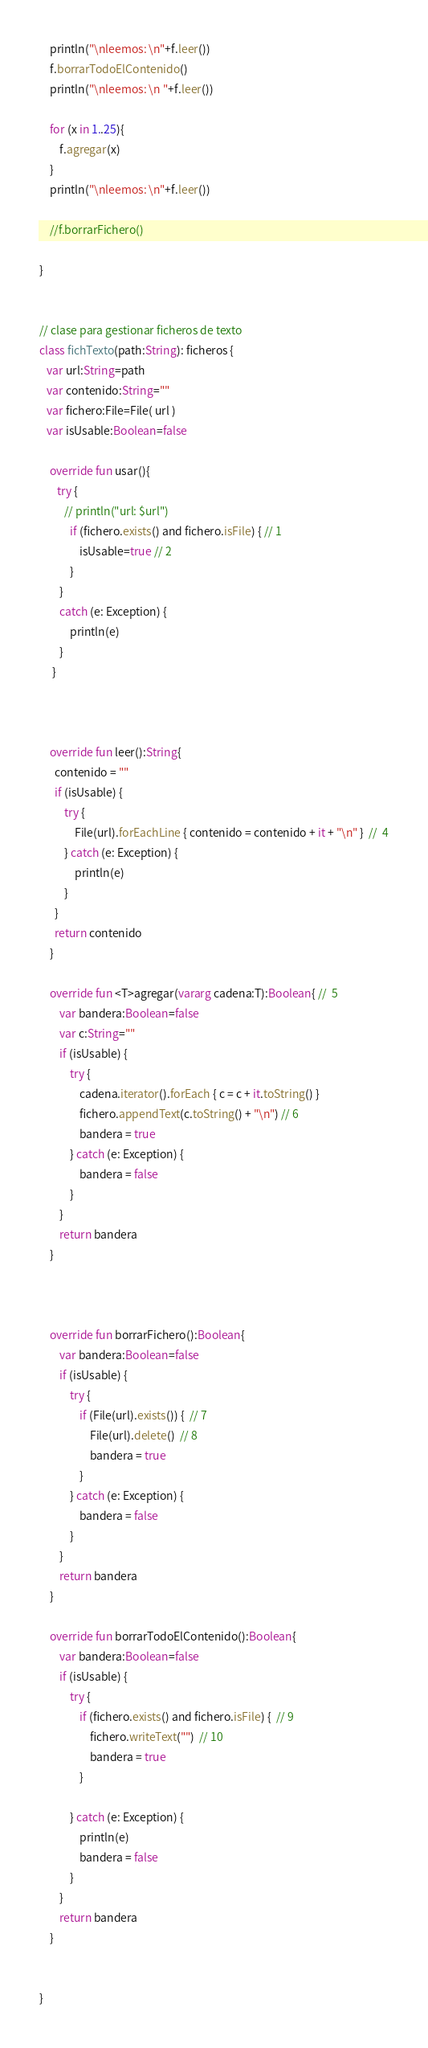Convert code to text. <code><loc_0><loc_0><loc_500><loc_500><_Kotlin_>    println("\nleemos: \n"+f.leer())
    f.borrarTodoElContenido()
    println("\nleemos: \n "+f.leer())

    for (x in 1..25){
        f.agregar(x)
    }
    println("\nleemos: \n"+f.leer())

    //f.borrarFichero()

}


// clase para gestionar ficheros de texto
class fichTexto(path:String): ficheros {
   var url:String=path
   var contenido:String=""
   var fichero:File=File( url )
   var isUsable:Boolean=false

    override fun usar(){
       try {
          // println("url: $url")
            if (fichero.exists() and fichero.isFile) { // 1
                isUsable=true // 2
            }
        }
        catch (e: Exception) {
            println(e)
        }
     }



    override fun leer():String{
      contenido = ""
      if (isUsable) {
          try {
              File(url).forEachLine { contenido = contenido + it + "\n" }  //  4
          } catch (e: Exception) {
              println(e)
          }
      }
      return contenido
    }

    override fun <T>agregar(vararg cadena:T):Boolean{ //  5
        var bandera:Boolean=false
        var c:String=""
        if (isUsable) {
            try {
                cadena.iterator().forEach { c = c + it.toString() }
                fichero.appendText(c.toString() + "\n") // 6
                bandera = true
            } catch (e: Exception) {
                bandera = false
            }
        }
        return bandera
    }



    override fun borrarFichero():Boolean{
        var bandera:Boolean=false
        if (isUsable) {
            try {
                if (File(url).exists()) {  // 7
                    File(url).delete()  // 8
                    bandera = true
                }
            } catch (e: Exception) {
                bandera = false
            }
        }
        return bandera
    }

    override fun borrarTodoElContenido():Boolean{
        var bandera:Boolean=false
        if (isUsable) {
            try {
                if (fichero.exists() and fichero.isFile) {  // 9
                    fichero.writeText("")  // 10
                    bandera = true
                }

            } catch (e: Exception) {
                println(e)
                bandera = false
            }
        }
        return bandera
    }


}</code> 